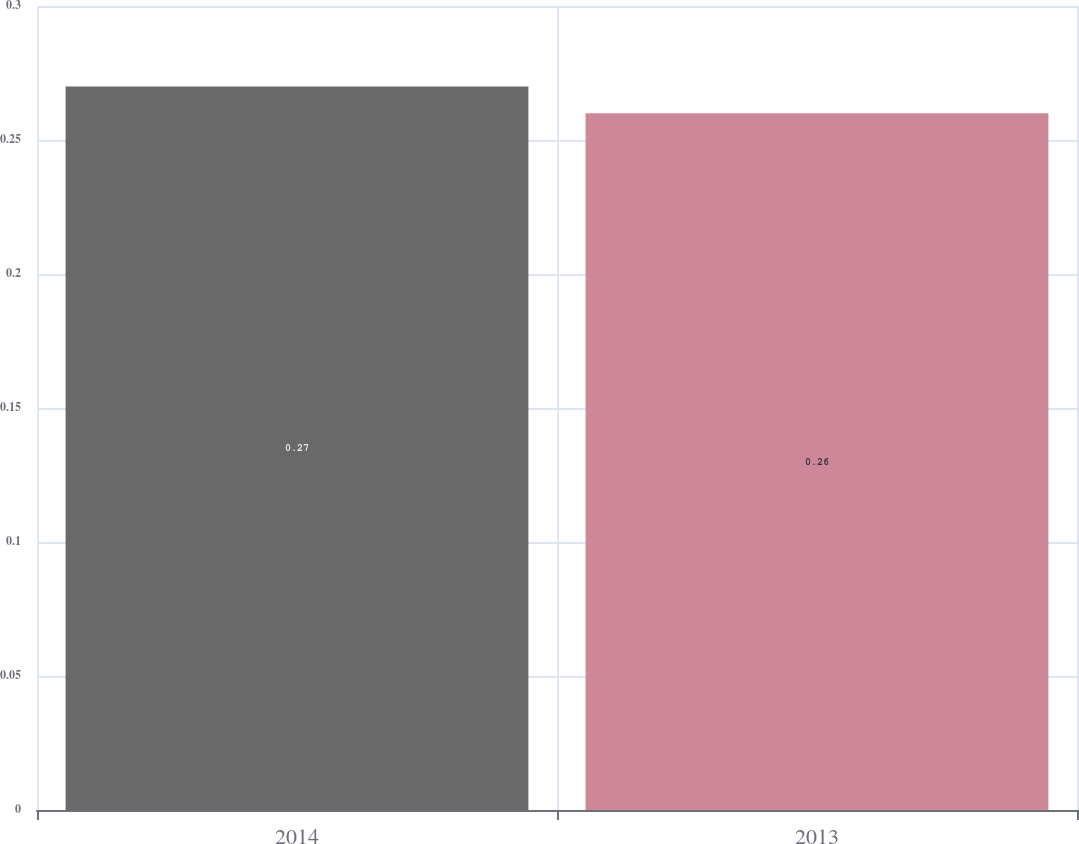Convert chart. <chart><loc_0><loc_0><loc_500><loc_500><bar_chart><fcel>2014<fcel>2013<nl><fcel>0.27<fcel>0.26<nl></chart> 